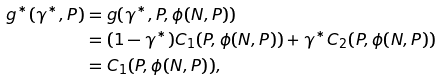<formula> <loc_0><loc_0><loc_500><loc_500>g ^ { * } ( \gamma ^ { * } , P ) & = g ( \gamma ^ { * } , P , \phi ( N , P ) ) \\ & = ( 1 - \gamma ^ { * } ) C _ { 1 } ( P , \phi ( N , P ) ) + \gamma ^ { * } C _ { 2 } ( P , \phi ( N , P ) ) \\ & = C _ { 1 } ( P , \phi ( N , P ) ) ,</formula> 